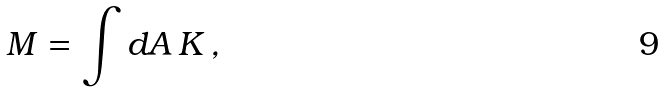<formula> <loc_0><loc_0><loc_500><loc_500>M = \int d A \, K \, ,</formula> 